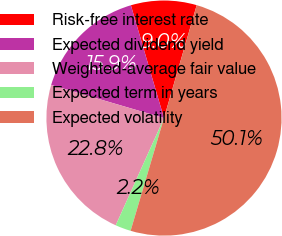Convert chart to OTSL. <chart><loc_0><loc_0><loc_500><loc_500><pie_chart><fcel>Risk-free interest rate<fcel>Expected dividend yield<fcel>Weighted-average fair value<fcel>Expected term in years<fcel>Expected volatility<nl><fcel>9.03%<fcel>15.92%<fcel>22.81%<fcel>2.15%<fcel>50.09%<nl></chart> 